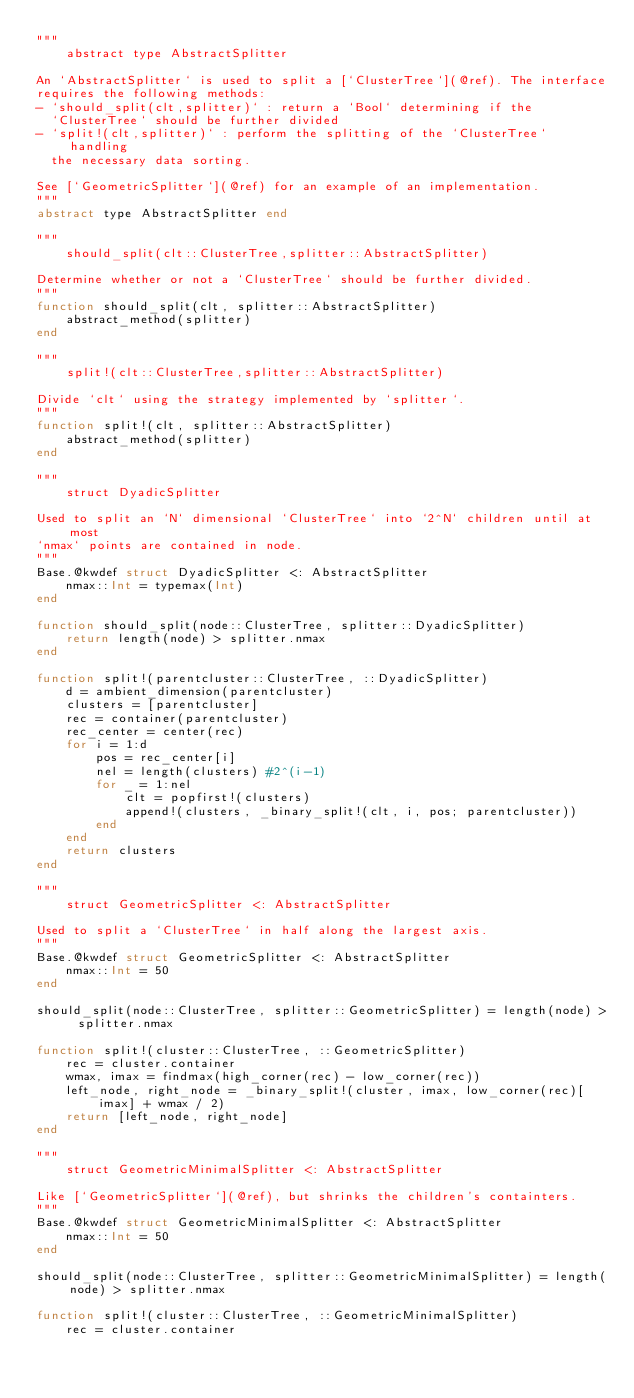Convert code to text. <code><loc_0><loc_0><loc_500><loc_500><_Julia_>"""
    abstract type AbstractSplitter

An `AbstractSplitter` is used to split a [`ClusterTree`](@ref). The interface
requires the following methods:
- `should_split(clt,splitter)` : return a `Bool` determining if the
  `ClusterTree` should be further divided
- `split!(clt,splitter)` : perform the splitting of the `ClusterTree` handling
  the necessary data sorting.

See [`GeometricSplitter`](@ref) for an example of an implementation.
"""
abstract type AbstractSplitter end

"""
    should_split(clt::ClusterTree,splitter::AbstractSplitter)

Determine whether or not a `ClusterTree` should be further divided.
"""
function should_split(clt, splitter::AbstractSplitter)
    abstract_method(splitter)
end

"""
    split!(clt::ClusterTree,splitter::AbstractSplitter)

Divide `clt` using the strategy implemented by `splitter`.
"""
function split!(clt, splitter::AbstractSplitter)
    abstract_method(splitter)
end

"""
    struct DyadicSplitter

Used to split an `N` dimensional `ClusterTree` into `2^N` children until at most
`nmax` points are contained in node.
"""
Base.@kwdef struct DyadicSplitter <: AbstractSplitter
    nmax::Int = typemax(Int)
end

function should_split(node::ClusterTree, splitter::DyadicSplitter)
    return length(node) > splitter.nmax
end

function split!(parentcluster::ClusterTree, ::DyadicSplitter)
    d = ambient_dimension(parentcluster)
    clusters = [parentcluster]
    rec = container(parentcluster)
    rec_center = center(rec)
    for i = 1:d
        pos = rec_center[i]
        nel = length(clusters) #2^(i-1)
        for _ = 1:nel
            clt = popfirst!(clusters)
            append!(clusters, _binary_split!(clt, i, pos; parentcluster))
        end
    end
    return clusters
end

"""
    struct GeometricSplitter <: AbstractSplitter

Used to split a `ClusterTree` in half along the largest axis.
"""
Base.@kwdef struct GeometricSplitter <: AbstractSplitter
    nmax::Int = 50
end

should_split(node::ClusterTree, splitter::GeometricSplitter) = length(node) > splitter.nmax

function split!(cluster::ClusterTree, ::GeometricSplitter)
    rec = cluster.container
    wmax, imax = findmax(high_corner(rec) - low_corner(rec))
    left_node, right_node = _binary_split!(cluster, imax, low_corner(rec)[imax] + wmax / 2)
    return [left_node, right_node]
end

"""
    struct GeometricMinimalSplitter <: AbstractSplitter

Like [`GeometricSplitter`](@ref), but shrinks the children's containters.
"""
Base.@kwdef struct GeometricMinimalSplitter <: AbstractSplitter
    nmax::Int = 50
end

should_split(node::ClusterTree, splitter::GeometricMinimalSplitter) = length(node) > splitter.nmax

function split!(cluster::ClusterTree, ::GeometricMinimalSplitter)
    rec = cluster.container</code> 